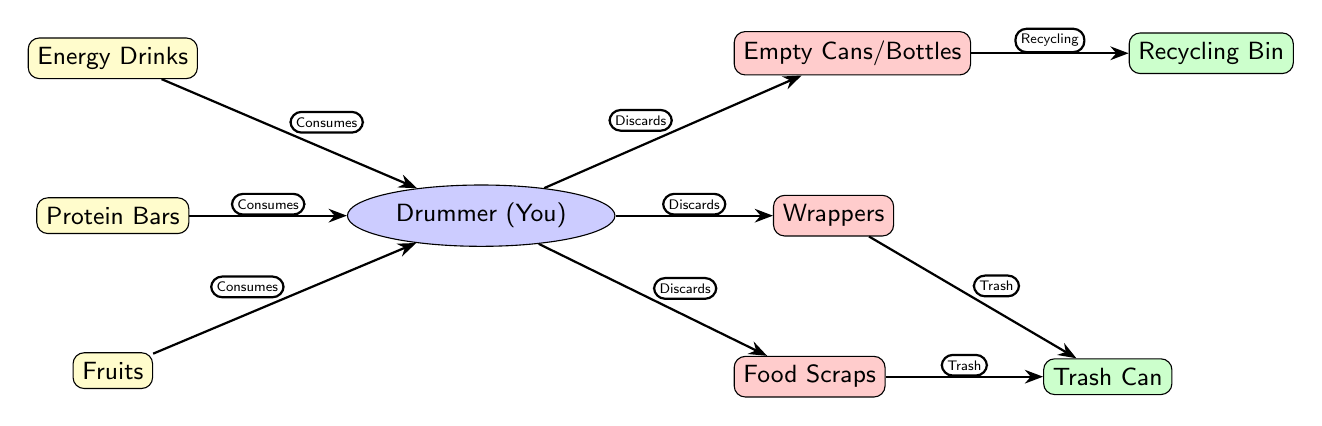What food items are consumed? The diagram lists three food items consumed by the drummer: Energy Drinks, Protein Bars, and Fruits.
Answer: Energy Drinks, Protein Bars, Fruits How many types of waste are generated? The drummer discards three types of waste: Empty Cans/Bottles, Wrappers, and Food Scraps. Therefore, there are three types of waste generated.
Answer: 3 What does the drummer discard that can be recycled? The diagram indicates that the Empty Cans/Bottles can be recycled. This is the only type of waste that is recyclable.
Answer: Empty Cans/Bottles What bin do food scraps go into? According to the diagram, Food Scraps are discarded into the Trash Can and not into a recycling bin, meaning they go into the Trash Can.
Answer: Trash Can Which food item is at the top of the food chain? The diagram places Energy Drinks at the top of the food chain. It is the first food item listed, indicating its primary role in the food chain.
Answer: Energy Drinks How does the drummer interact with protein bars? The drummer consumes protein bars as indicated by the arrow labeled "Consumes" connecting Protein Bars to the drummer.
Answer: Consumes What is the relationship between the drummer and the Trash Can? The drummer discards actions directed towards the Trash Can, as indicated by the "Discards" arrows leading from the drummer to both the Trash Can and Recycling Bin for different types of waste.
Answer: Discards What type of node is the Recycling Bin? The Recycling Bin is categorized as a rectangular-shaped node filled with green color, indicating that it is a waste bin.
Answer: Rectangle What is the total number of connections in this food chain? Analyzing the diagram reveals that there are a total of 7 connections or edges: three "Consumes" from the food items to the drummer, three "Discards" from the drummer to the waste types, and two "Recycling" and "Trash" connections from the waste types to their respective bins.
Answer: 8 